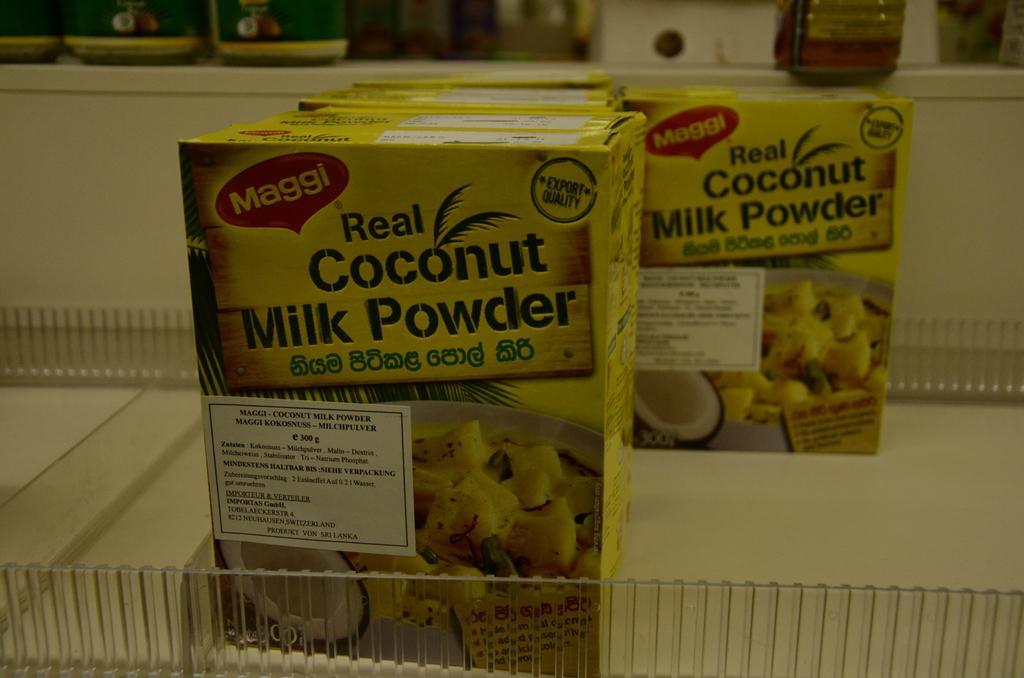What type of powder is present in the image? There are coconut powders in the image. What else can be seen on the table in the image? There are other objects on the table in the image, but their specific details are not mentioned in the provided facts. Who is the stranger giving a birth to a baby in the image? There is no stranger or baby in the image; it only features coconut powders and other objects on the table. 